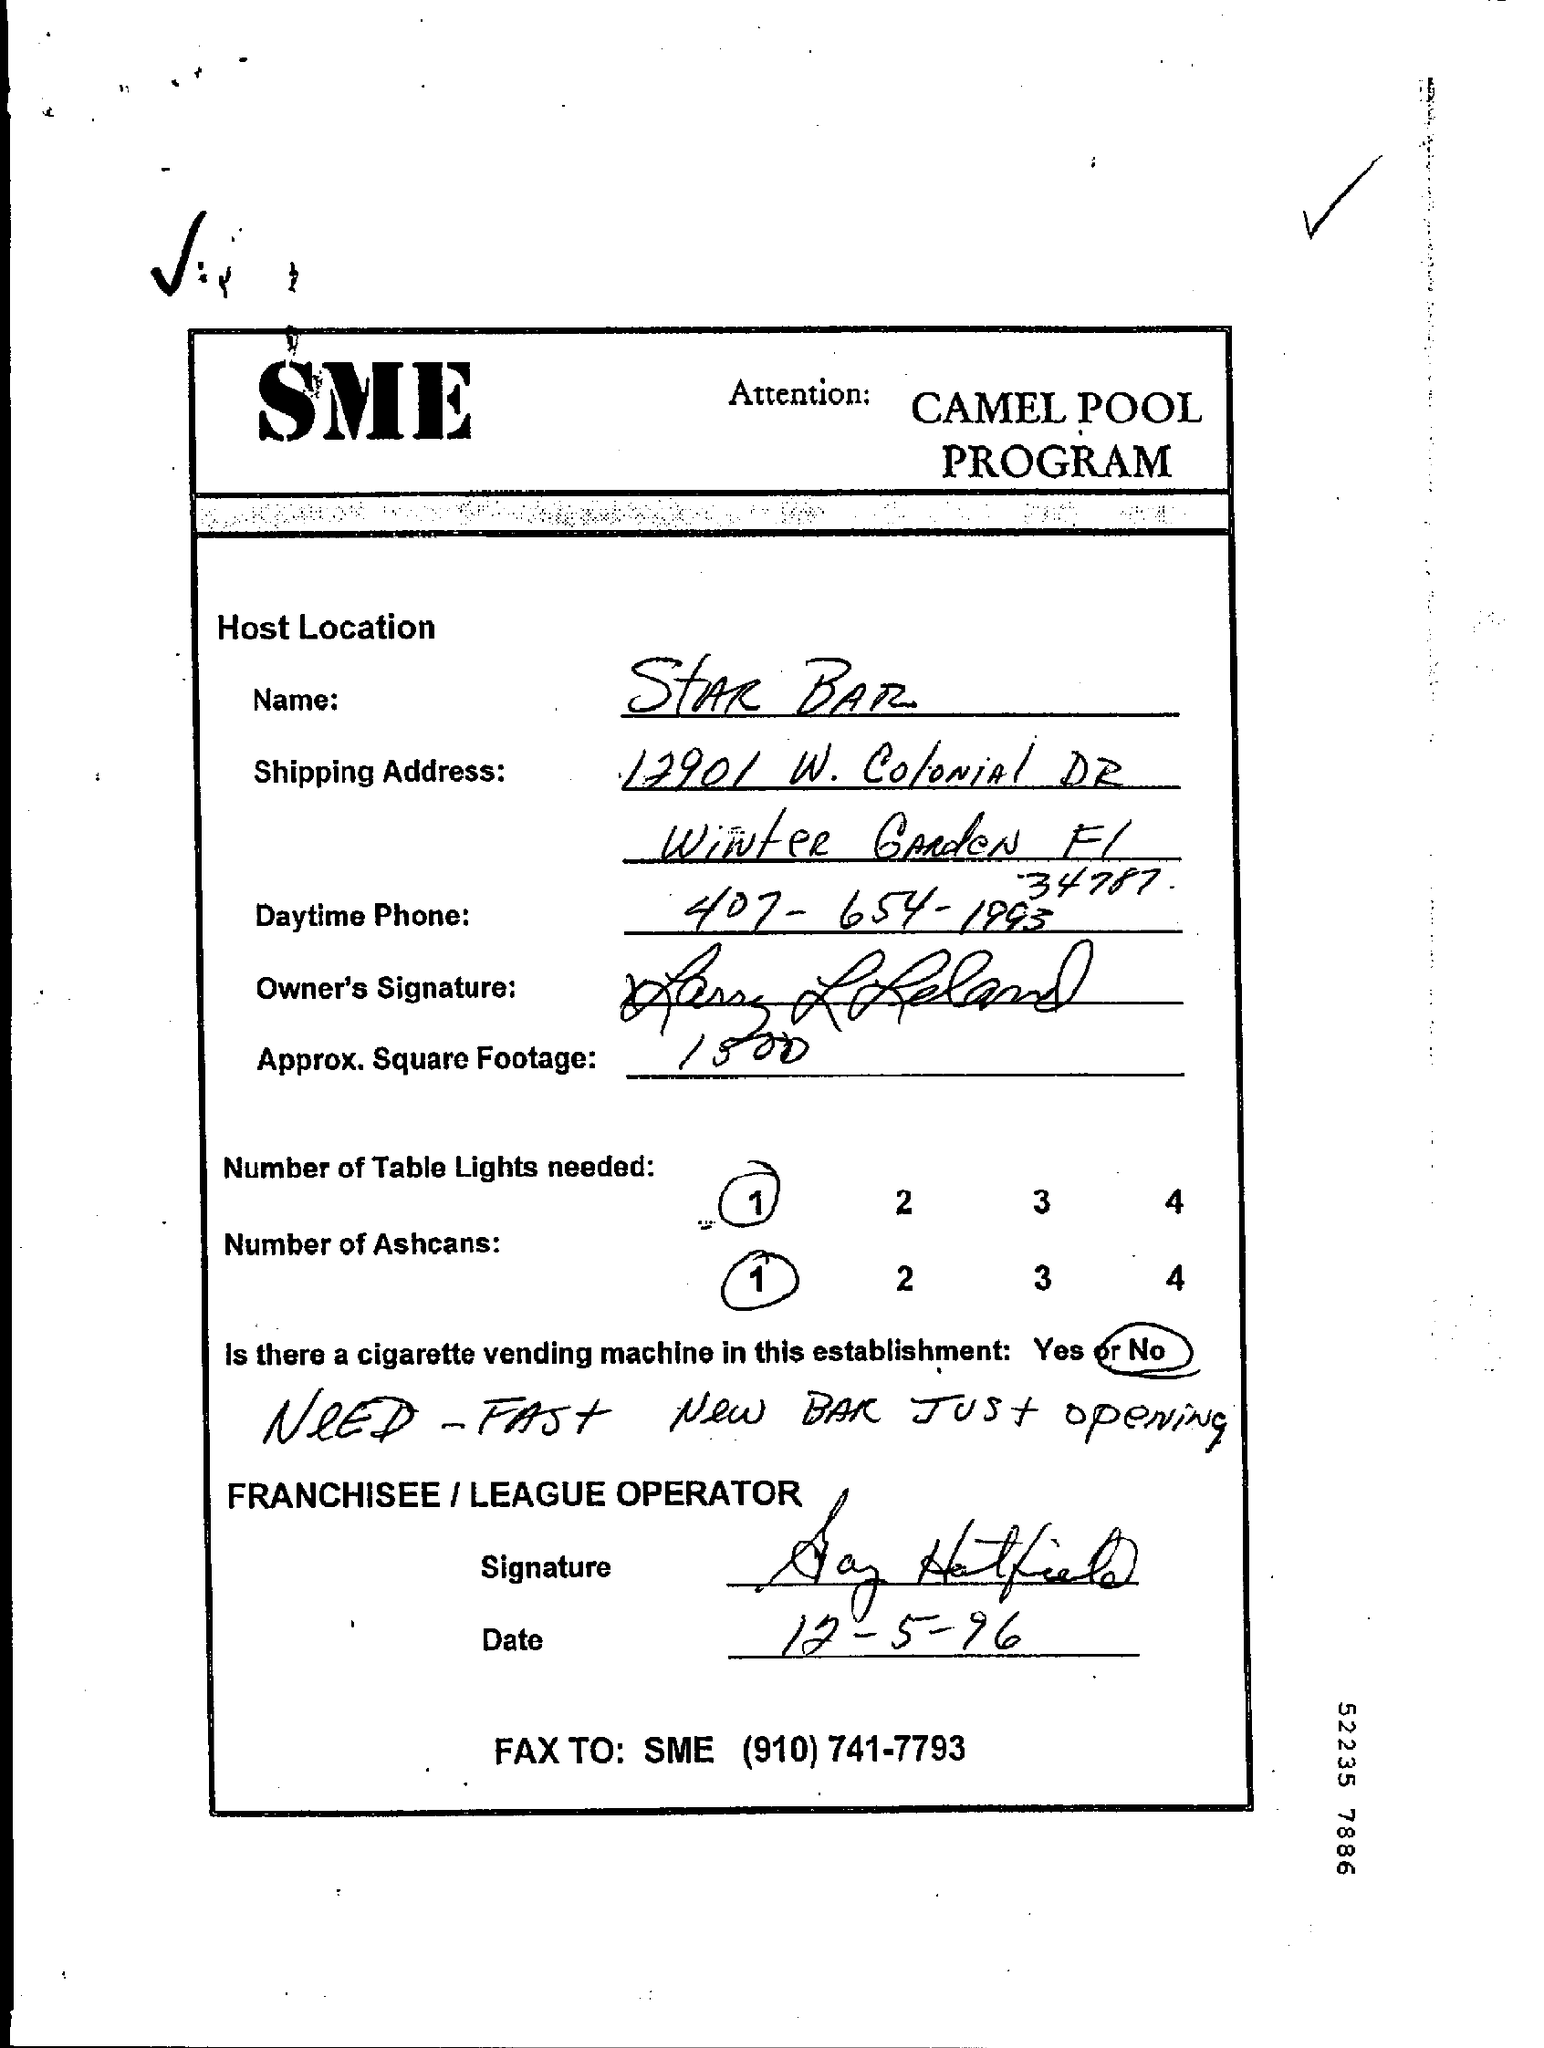What is the name of the host location ?
Your answer should be very brief. Star bar. What is the day time phone number given in the page ?
Provide a succinct answer. 407-654-1993. What is the value of approx.square footage ?
Provide a succinct answer. 1500. How many number of table lights needed as mentioned in the given page ?
Provide a succinct answer. 1. What is the name of the program ?
Make the answer very short. Camel pool program. How many number of ashcans are needed as mentioned in the given page ?
Keep it short and to the point. 1. Is there a cigarette vending machine in this establishment ?
Give a very brief answer. No. 